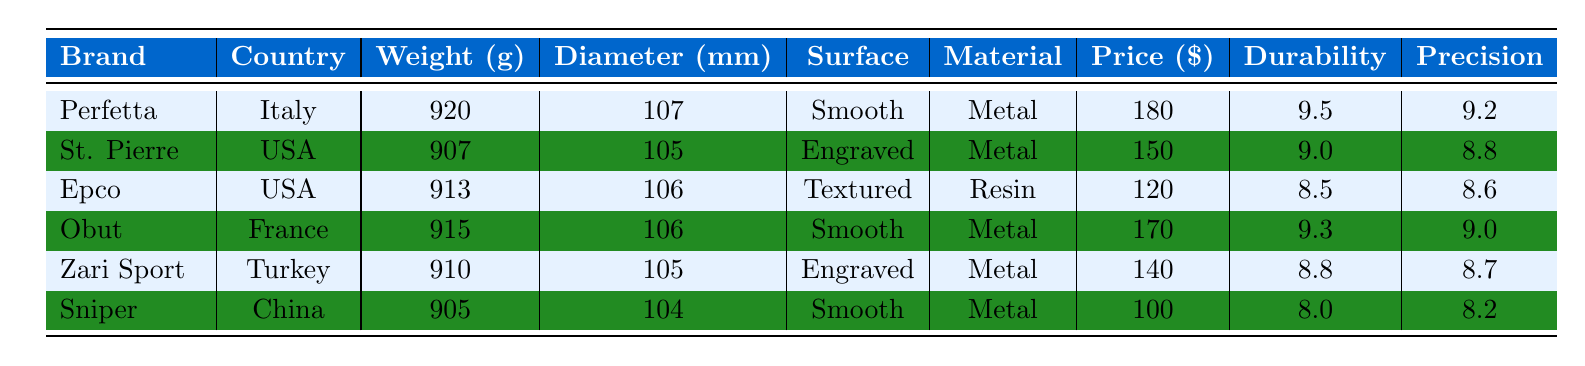What is the weight of the Perfetta bocce ball? The table lists the weight of the Perfetta bocce ball under the "Weight (g)" column, which shows a value of 920 grams.
Answer: 920 grams Which brand has the highest durability rating? By reviewing the "Durability" column, the highest rating is 9.5 associated with the Perfetta brand.
Answer: Perfetta Is the Epco bocce ball suitable for outdoor play? The table indicates the suitability for outdoor play under the "Suitable for outdoor" column, where Epco has a value of "No".
Answer: No What is the average weight of the bocce balls listed in the table? The weights are (920 + 907 + 913 + 915 + 910 + 905) = 5780 grams. There are 6 brands, so the average weight is 5780 / 6 = 963.33 grams.
Answer: 963.33 grams Are the St. Pierre and Obut bocce balls popular among professionals? Checking the "Popular among pros" column, both St. Pierre and Obut are marked as "Yes".
Answer: Yes What is the precision score difference between the best and worst performing brands? The highest precision score is 9.2 (Perfetta) and the lowest is 8.2 (Sniper). Therefore, the difference is 9.2 - 8.2 = 1.0.
Answer: 1.0 Which brand has the lowest price among the listed bocce balls? The prices are compared in the "Price ($)" column, with Sniper at 100 being the lowest price.
Answer: Sniper How many bocce balls are made of metal? The material column lists "Metal" for Perfetta, St. Pierre, Obut, Zari Sport, and Sniper, which totals to 5 brands.
Answer: 5 brands Is the Zari Sport bocce ball more expensive than the Sniper bocce ball? The prices are compared and Zari Sport at 140 is more expensive than Sniper at 100, confirming the answer.
Answer: Yes 